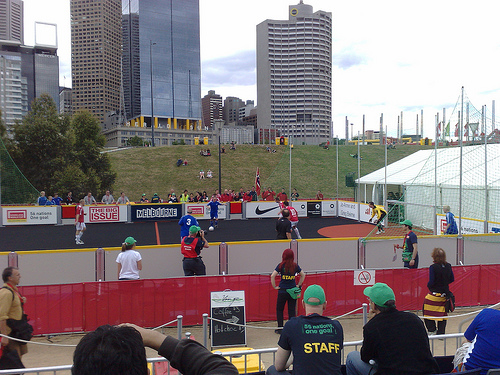<image>
Can you confirm if the land is on the building? No. The land is not positioned on the building. They may be near each other, but the land is not supported by or resting on top of the building. 